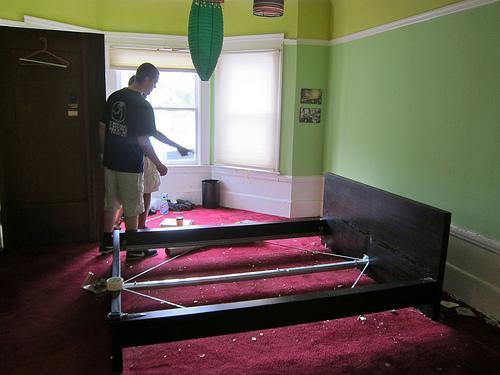How many people are there?
Give a very brief answer. 2. 